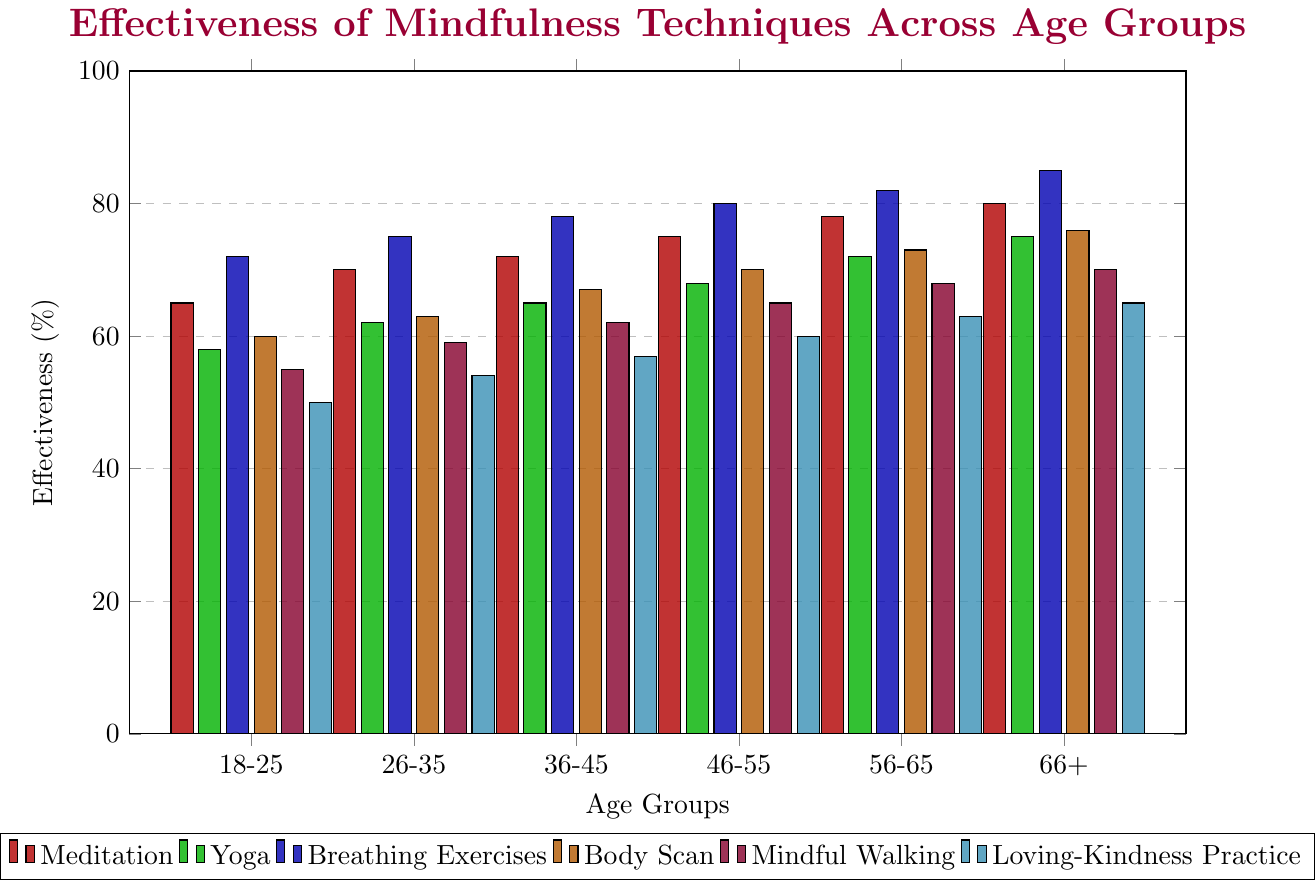What age group finds the highest effectiveness in Breathing Exercises? To find the age group with the highest effectiveness for Breathing Exercises, look at the figure and locate the tallest blue bar. According to the chart, the tallest blue bar is for the 66+ age group. Therefore, the 66+ age group finds the highest effectiveness in Breathing Exercises.
Answer: 66+ Which mindfulness technique is least effective for the 18-25 age group? To determine the least effective technique for the 18-25 age group, look at the heights of the bars corresponding to this group in the chart. The shortest bar for the 18-25 age group is cyan, representing Loving-Kindness Practice.
Answer: Loving-Kindness Practice For the 36-45 age group, how much more effective is Body Scan compared to Mindful Walking? To find the effectiveness of Body Scan and Mindful Walking for the 36-45 age group, locate the orange and purple bars respectively. Body Scan has an effectiveness of 67%, and Mindful Walking has 62%. Thus, Body Scan is 67% - 62% = 5% more effective than Mindful Walking.
Answer: 5% Which age group has the lowest effectiveness for Yoga? To find the age group with the lowest effectiveness for Yoga, identify the shortest green bar in the figure. The shortest green bar corresponds to the 18-25 age group.
Answer: 18-25 Compare the effectiveness of Meditation and Yoga for the 46-55 age group. Which is more effective? To compare the effectiveness, locate the red and green bars for the 46-55 age group. The red bar (Meditation) is at 75%, and the green bar (Yoga) is at 68%. Therefore, Meditation is more effective than Yoga for this age group.
Answer: Meditation What is the average effectiveness of Body Scan across all age groups? Sum the effectiveness percentages for Body Scan across all age groups: 60 + 63 + 67 + 70 + 73 + 76 = 409. Then divide by the number of age groups: 409 / 6 = 68.17%.
Answer: 68.17% For the 56-65 age group, are any two mindfulness techniques equally effective? If so, which ones? Find the bars for the 56-65 age group and check for any equal heights. None of the bars are of equal height, indicating no two techniques are equally effective for this group.
Answer: No Which mindfulness technique shows the greatest increase in effectiveness from the 18-25 to 66+ age group? Calculate the increase in effectiveness for each technique by comparing the values for the 66+ and 18-25 age groups and find the maximum increase. For Meditation: 80 - 65 = 15; for Yoga: 75 - 58 = 17; for Breathing Exercises: 85 - 72 = 13; for Body Scan: 76 - 60 = 16; for Mindful Walking: 70 - 55 = 15; for Loving-Kindness Practice: 65 - 50 = 15. Yoga shows the greatest increase, which is 17%.
Answer: Yoga 